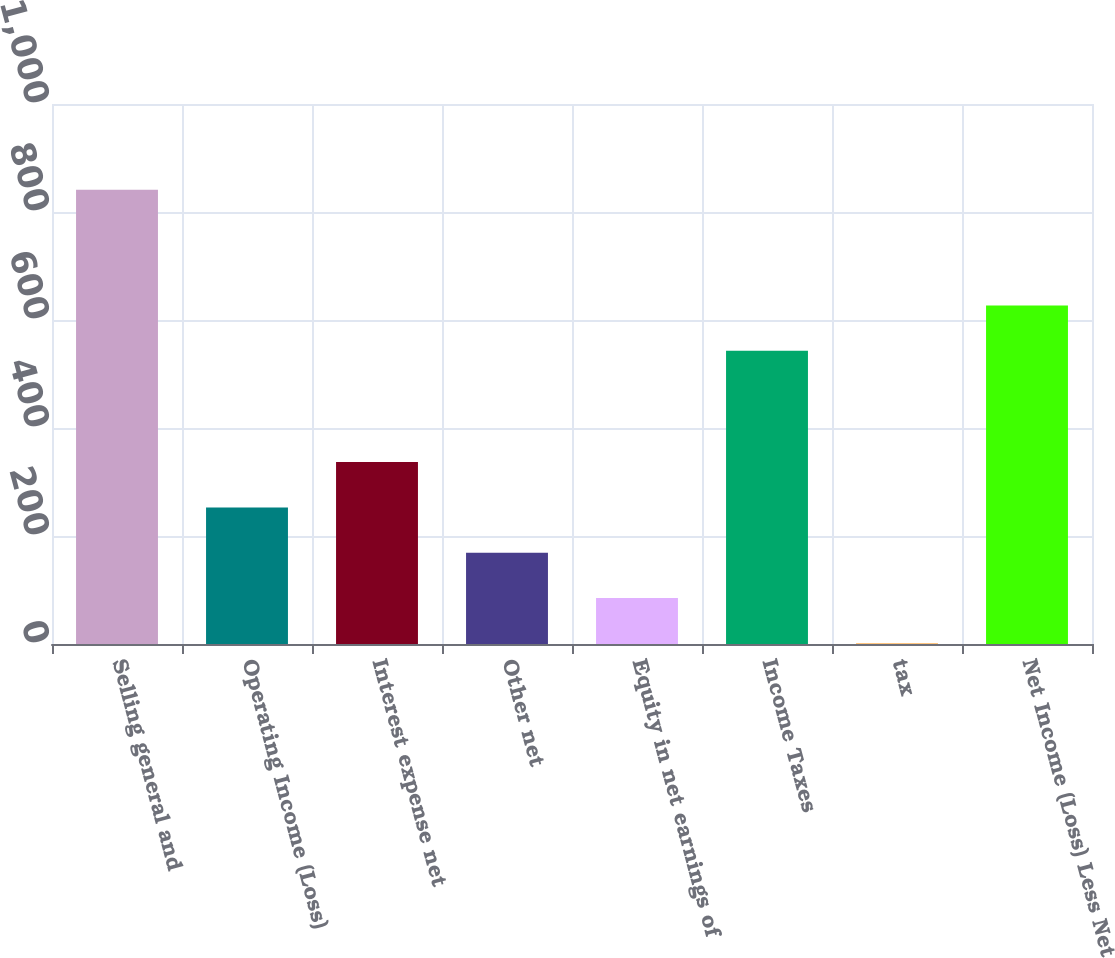Convert chart to OTSL. <chart><loc_0><loc_0><loc_500><loc_500><bar_chart><fcel>Selling general and<fcel>Operating Income (Loss)<fcel>Interest expense net<fcel>Other net<fcel>Equity in net earnings of<fcel>Income Taxes<fcel>tax<fcel>Net Income (Loss) Less Net<nl><fcel>841<fcel>253<fcel>337<fcel>169<fcel>85<fcel>543<fcel>1<fcel>627<nl></chart> 